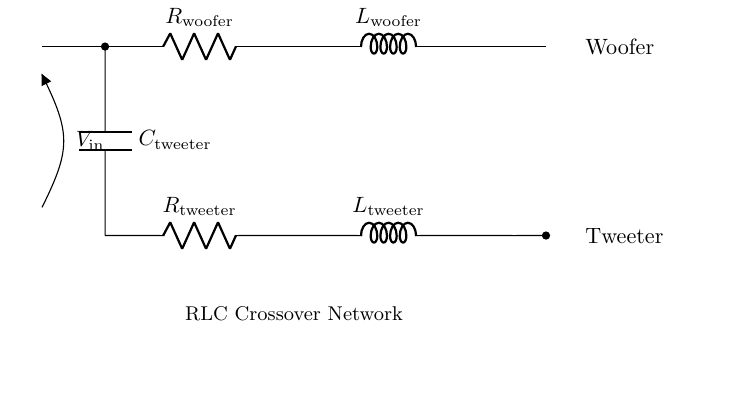What components are present in this circuit? The circuit contains a resistor, an inductor, and a capacitor, as indicated by the labels on each component. Their specific designations for the woofer and tweeter segments are also marked.
Answer: resistor, inductor, capacitor What type of circuit is this? This is an RLC circuit, which includes resistors, inductors, and capacitors that are used for filtering audio frequencies in a crossover network for loudspeakers.
Answer: RLC circuit How many branches are there in the circuit? The circuit has two separate branches: one for the woofer and one for the tweeter, as indicated by their respective components and the parallel connection of the capacitor to the input.
Answer: two Which component is connected to the woofer? The components connected to the woofer are the resistor and inductor labeled as R woofer and L woofer.
Answer: R woofer, L woofer What is the function of the capacitor in this circuit? The capacitor is used to block low-frequency audio signals, allowing only high-frequency signals to pass to the tweeter, effectively filtering the sound frequencies.
Answer: filtering What happens when the input voltage increases? When the input voltage increases, the amount of current through the circuit will increase according to Ohm’s Law, potentially affecting the performance of both the woofer and tweeter based on their impedance at different frequencies.
Answer: increases current What is the role of the inductor in this circuit? The inductor serves to block high-frequency signals while allowing low-frequency signals to pass through, thus helping to separate the frequency ranges between the woofer and tweeter.
Answer: block high frequencies 